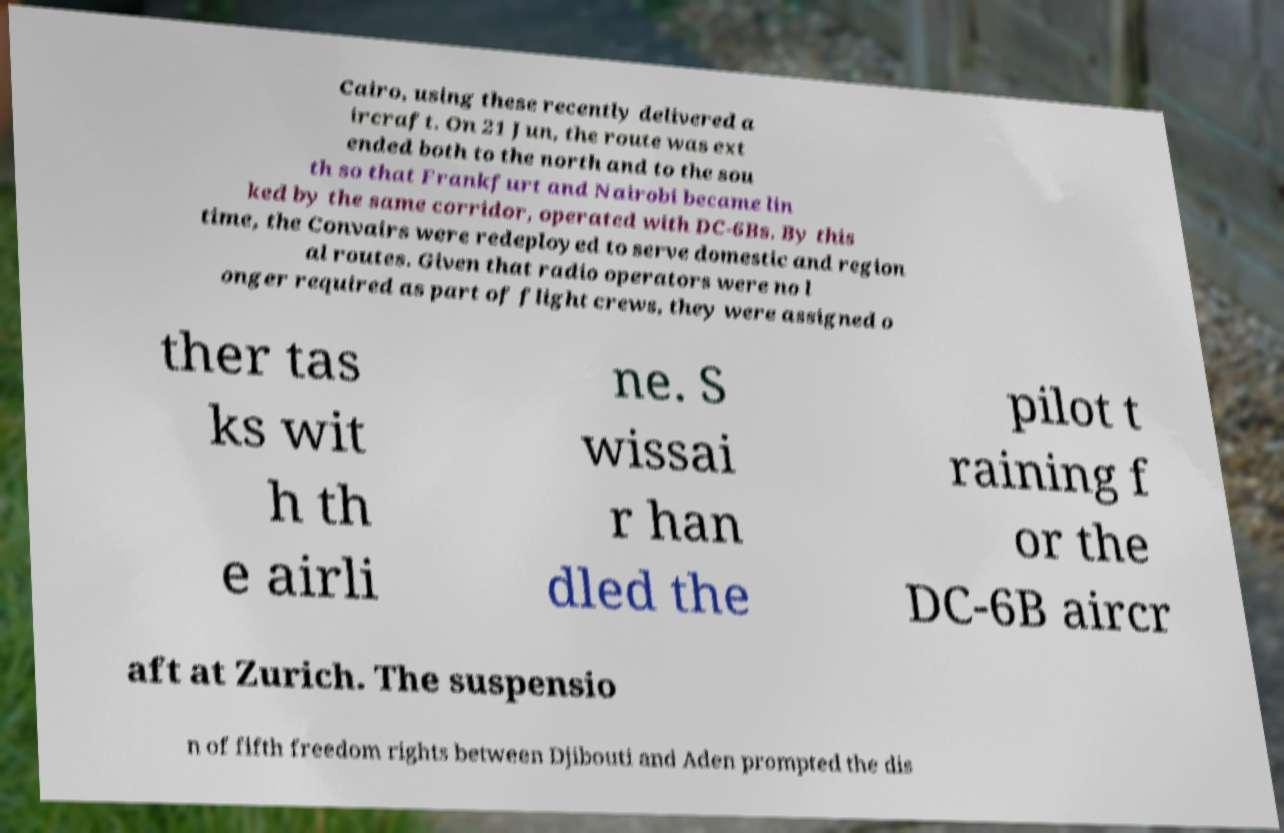For documentation purposes, I need the text within this image transcribed. Could you provide that? Cairo, using these recently delivered a ircraft. On 21 Jun, the route was ext ended both to the north and to the sou th so that Frankfurt and Nairobi became lin ked by the same corridor, operated with DC-6Bs. By this time, the Convairs were redeployed to serve domestic and region al routes. Given that radio operators were no l onger required as part of flight crews, they were assigned o ther tas ks wit h th e airli ne. S wissai r han dled the pilot t raining f or the DC-6B aircr aft at Zurich. The suspensio n of fifth freedom rights between Djibouti and Aden prompted the dis 